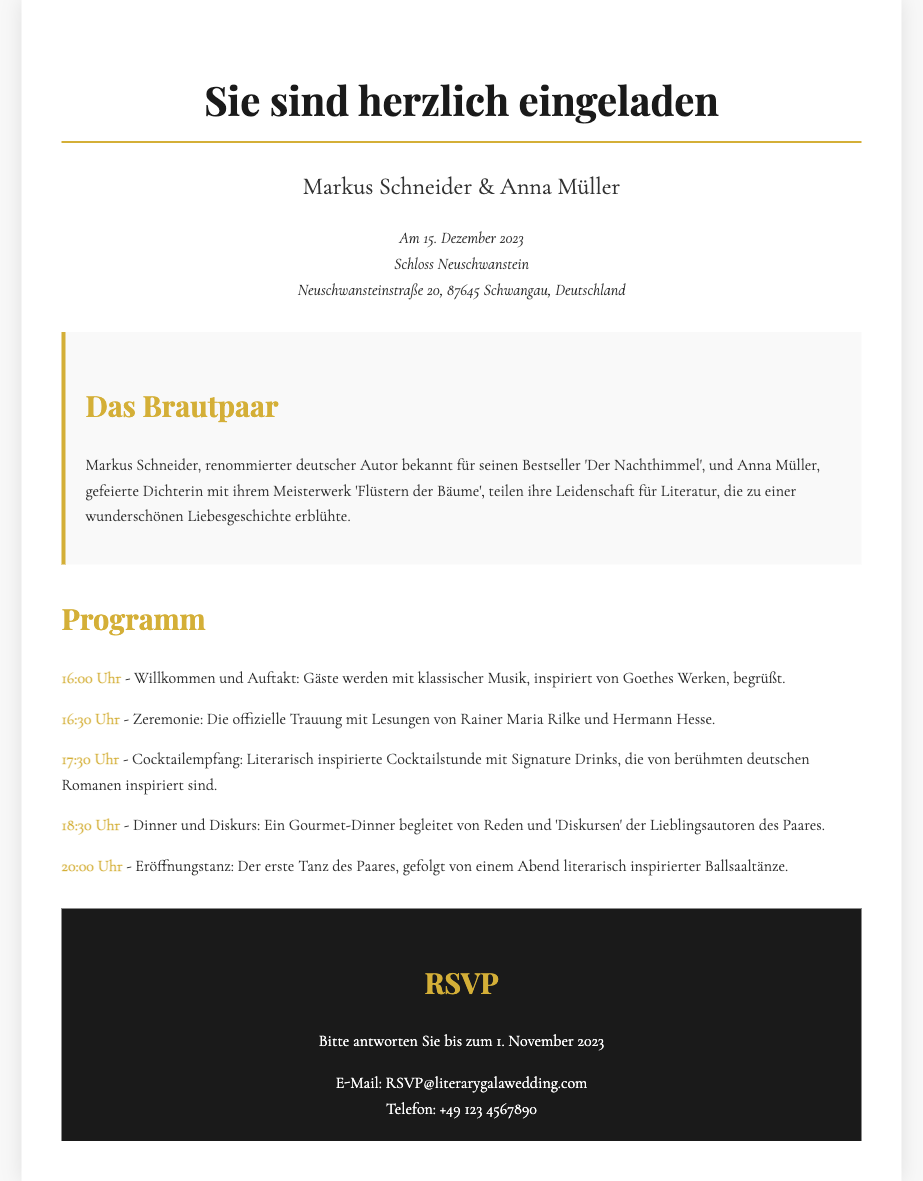What is the date of the wedding? The date of the wedding is clearly stated in the document.
Answer: 15. Dezember 2023 Where is the wedding taking place? The location of the wedding is mentioned in the invitation.
Answer: Schloss Neuschwanstein Who are the couple getting married? The names of the couple are provided at the top of the invitation.
Answer: Markus Schneider & Anna Müller What is the first item on the itinerary? The first scheduled activity is listed as part of the program.
Answer: Willkommen und Auftakt What literary work is Anna Müller known for? The document includes a brief biography of the couple, specifying their works.
Answer: Flüstern der Bäume What time does the cocktail reception start? The itinerary specifies the exact time for each segment of the event.
Answer: 17:30 Uhr What is the RSVP deadline? The RSVP deadline is provided in the RSVP section of the invitation.
Answer: 1. November 2023 Which author is quoted during the ceremony? The ceremony includes readings from notable authors, mentioned in the program.
Answer: Rainer Maria Rilke What is the theme of the cocktail hour? The invitation describes the type of cocktails served during this time.
Answer: Literarisch inspirierte Cocktails 